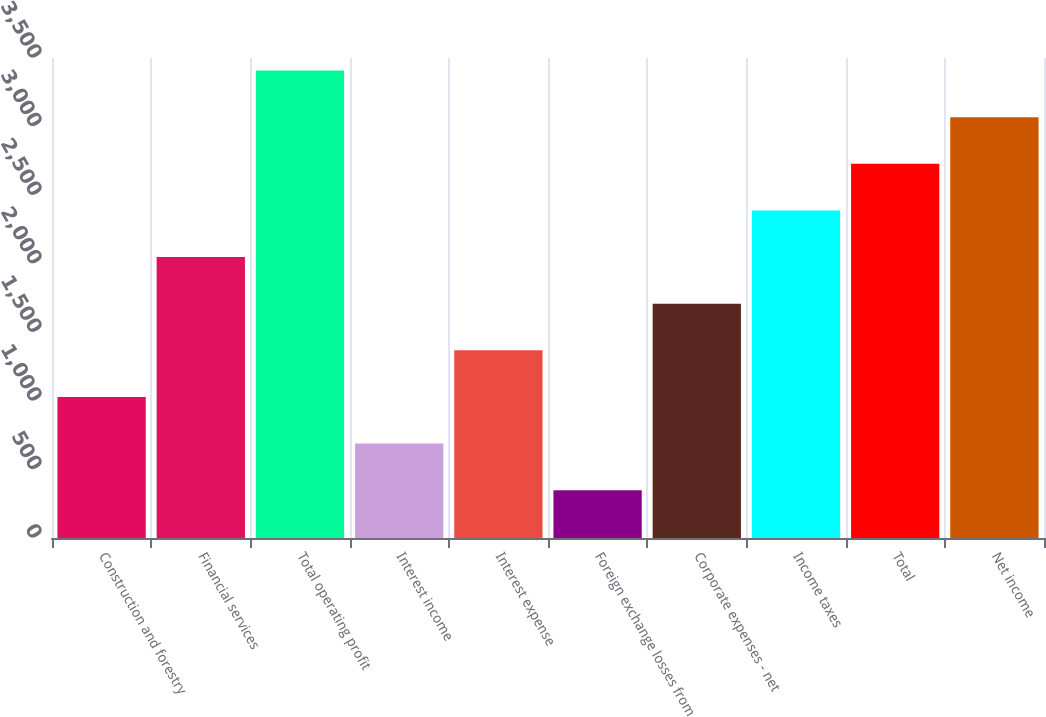Convert chart to OTSL. <chart><loc_0><loc_0><loc_500><loc_500><bar_chart><fcel>Construction and forestry<fcel>Financial services<fcel>Total operating profit<fcel>Interest income<fcel>Interest expense<fcel>Foreign exchange losses from<fcel>Corporate expenses - net<fcel>Income taxes<fcel>Total<fcel>Net income<nl><fcel>1028.7<fcel>2048.4<fcel>3408<fcel>688.8<fcel>1368.6<fcel>348.9<fcel>1708.5<fcel>2388.3<fcel>2728.2<fcel>3068.1<nl></chart> 